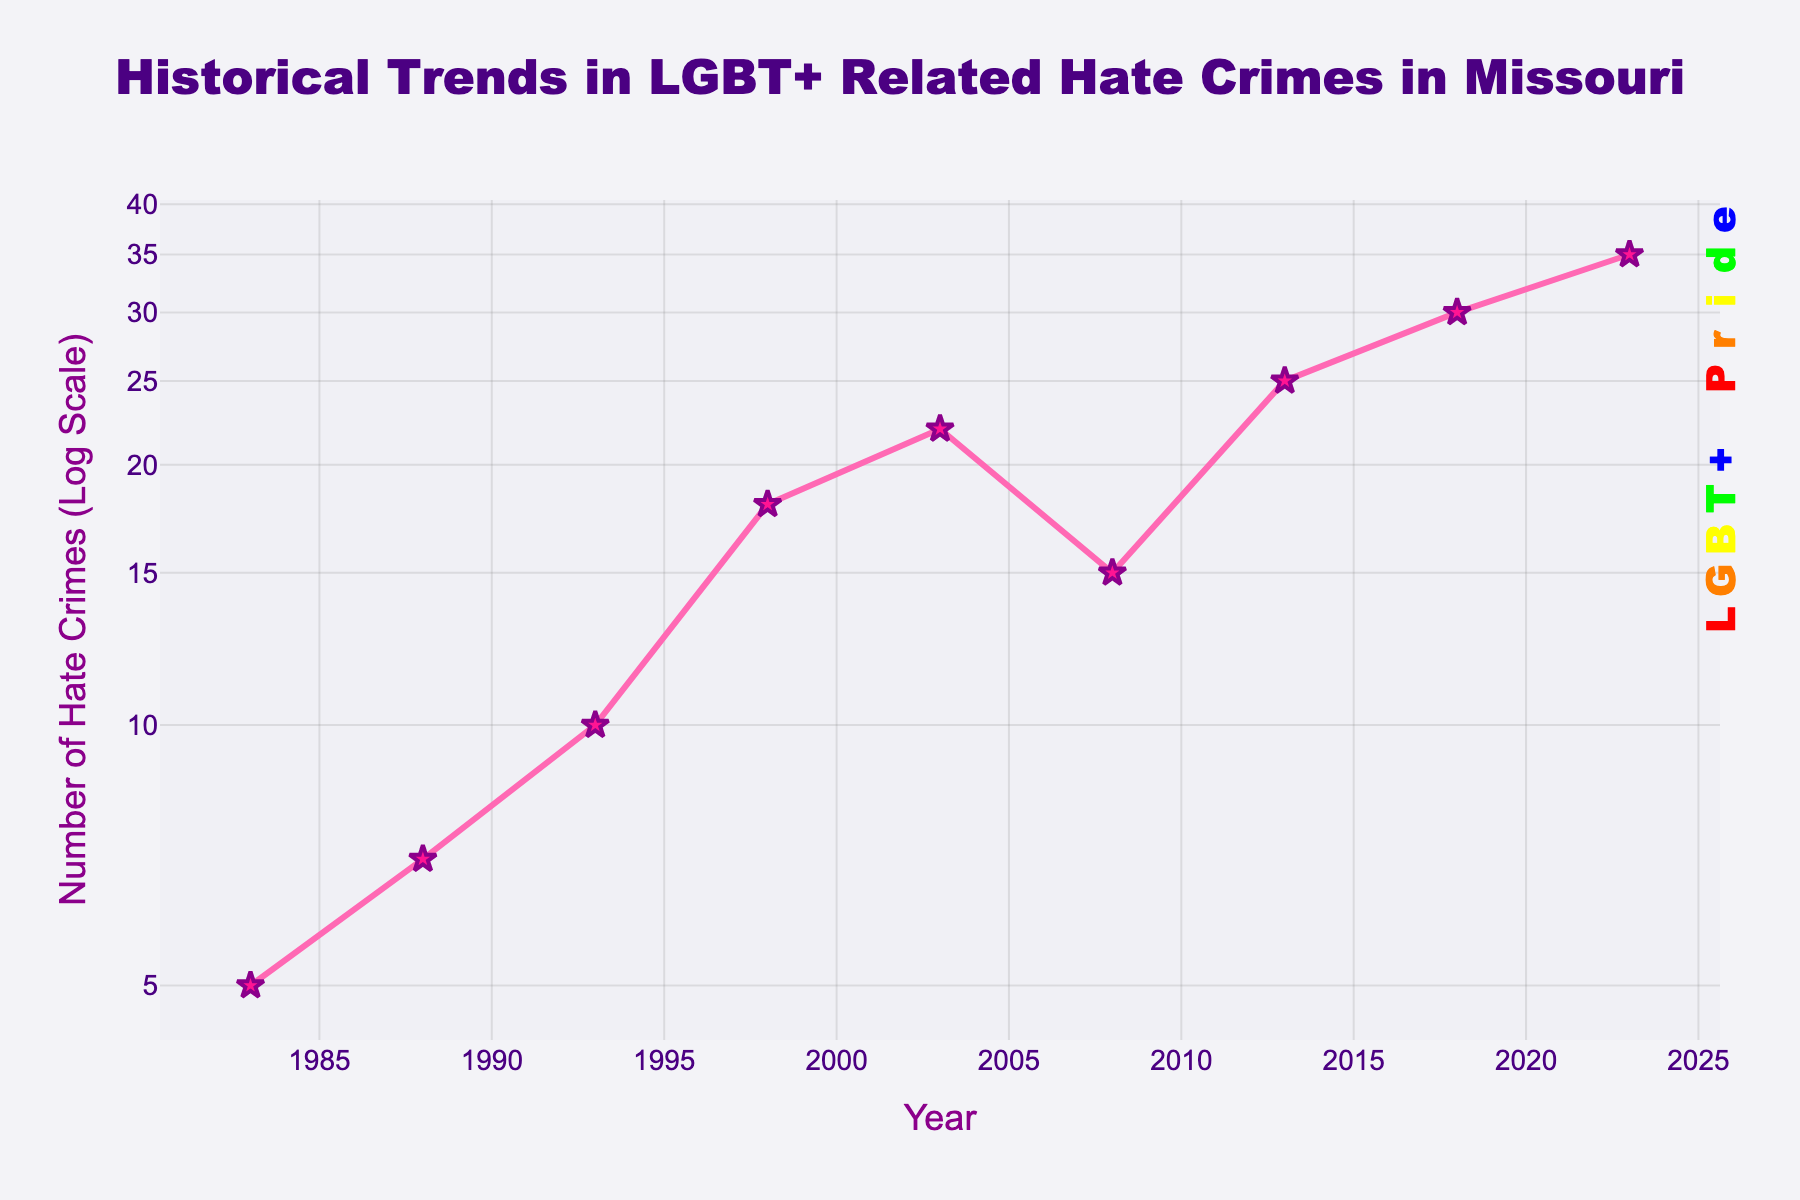what's the title of the figure? The title of the figure is displayed at the top. It reads, "Historical Trends in LGBT+ Related Hate Crimes in Missouri".
Answer: Historical Trends in LGBT+ Related Hate Crimes in Missouri how many data points are displayed in the figure? The number of data points can be counted by observing the markers on the plotted line. There are 9 markers shown for the years 1983, 1988, 1993, 1998, 2003, 2008, 2013, 2018, and 2023.
Answer: 9 what is the number of hate crimes reported in 2003? Locate the year 2003 on the x-axis and find the corresponding y-axis value. The label shows that 22 hate crimes were reported in 2003.
Answer: 22 between what years did the number of hate crimes increase the most? To determine the largest increase, calculate the differences between crime numbers for each pair of consecutive years. The largest increase occurs between 1993 (10) and 1998 (18), with an increase of 8.
Answer: 1993 and 1998 how does the number of hate crimes in 1983 compare to those in 2023? By comparing the y-axis values for 1983 (5) and 2023 (35), we see that 2023 has significantly more hate crimes than 1983. The exact comparison shows an increase from 5 to 35.
Answer: 2023 has more calculate the average number of hate crimes between 2003 and 2018. The hate crimes reported for 2003, 2008, and 2013, and 2018 are 22, 15, 25, and 30 respectively. Sum them up (22 + 15 + 25 + 30) and divide by the number of years (4): (92 / 4) = 23
Answer: 23 what colors are used for the line and marker symbols? The line is pink, and the marker symbols are pink stars with purple outlines.
Answer: pink and pink with purple outlines describe the trend in LGBT+ related hate crimes from 2008 to 2023. Observing the line plot from 2008 (15 hate crimes) to 2023 (35 hate crimes) shows a consistent increase in the number of hate crimes over the years.
Answer: increasing trend on what scale is the y-axis plotted? The y-axis is plotted on a logarithmic scale, which is indicated by the axis labels and the appearance of the scale values.
Answer: logarithmic scale how much did hate crimes increase between 2013 and 2023? Hate crimes in 2013 were 25, and in 2023 they were 35. The increase is 35 - 25 = 10.
Answer: 10 